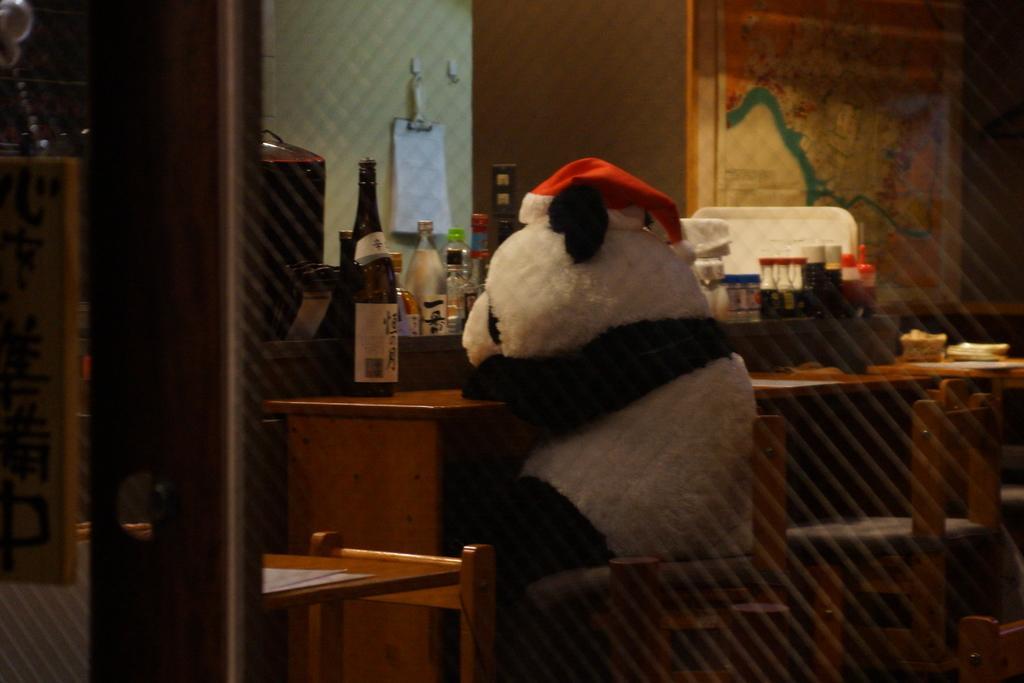How would you summarize this image in a sentence or two? The image is taken in the room. In the center of the image there is a clown sitting on the chair. There is a table. We can see bottles, cups, glasses placed on the table. In the background there is a wall. 